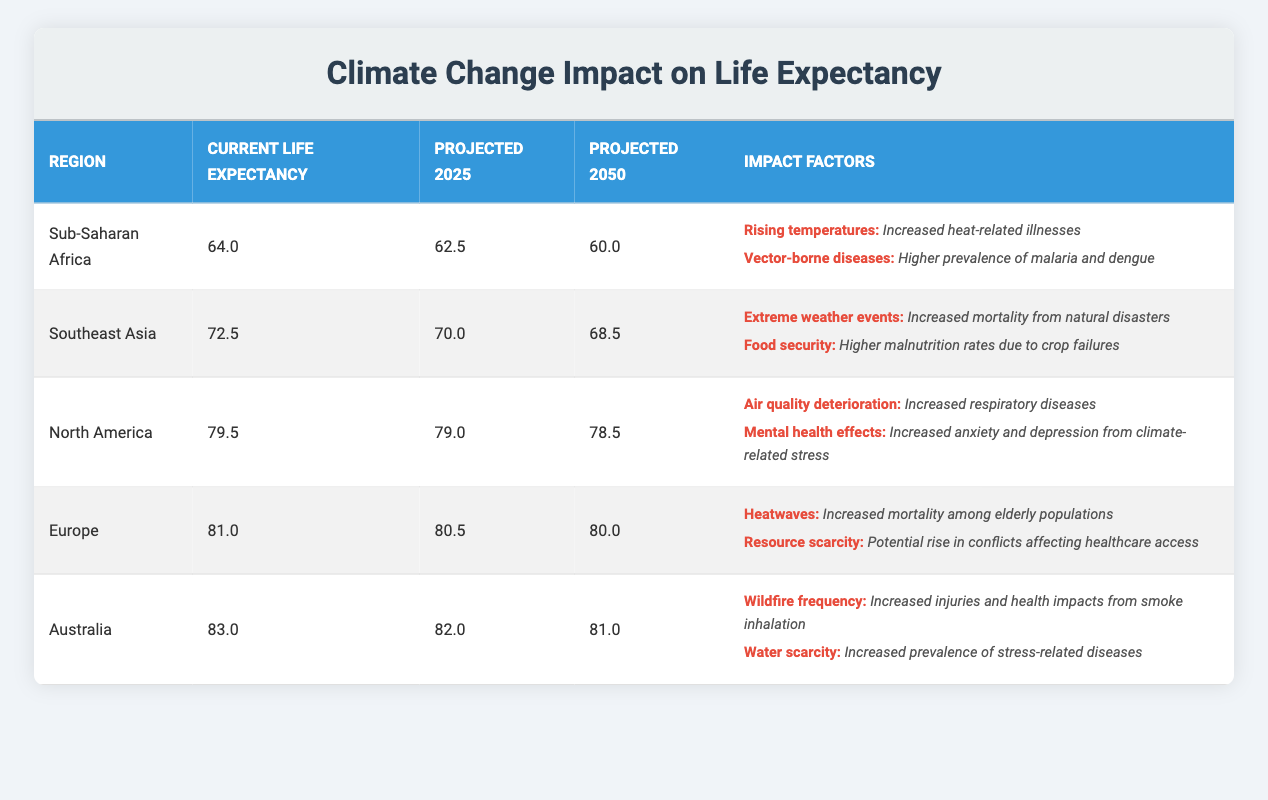What is the current life expectancy in Sub-Saharan Africa? The table lists the current life expectancy for each region. For Sub-Saharan Africa, it is specified as 64.0 years.
Answer: 64.0 What is the projected life expectancy for North America in 2025? From the table, the projected life expectancy for North America in 2025 is indicated as 79.0 years.
Answer: 79.0 Which region has the highest projected life expectancy for 2050? The table shows the projected life expectancy for each region in 2050. Australia has the highest at 81.0 years compared to other regions listed.
Answer: Australia Is the projected life expectancy for Southeast Asia in 2050 lower than that in 2025? The values indicate that the projected life expectancy for Southeast Asia in 2025 is 70.0 and in 2050 it is 68.5. Since 68.5 is less than 70.0, it confirms that it is lower.
Answer: Yes What is the average projected life expectancy across all regions for 2025? The projected life expectancies for 2025 are: Sub-Saharan Africa 62.5, Southeast Asia 70.0, North America 79.0, Europe 80.5, Australia 82.0. The average is calculated by summing these values (62.5 + 70.0 + 79.0 + 80.5 + 82.0 = 374.0) and dividing by the number of regions (5), thus 374.0 / 5 = 74.8.
Answer: 74.8 Which impact factor is associated with rising temperatures in Sub-Saharan Africa? Looking at the impact factors listed for Sub-Saharan Africa, rising temperatures is associated with increased heat-related illnesses directly stated in the table.
Answer: Increased heat-related illnesses 